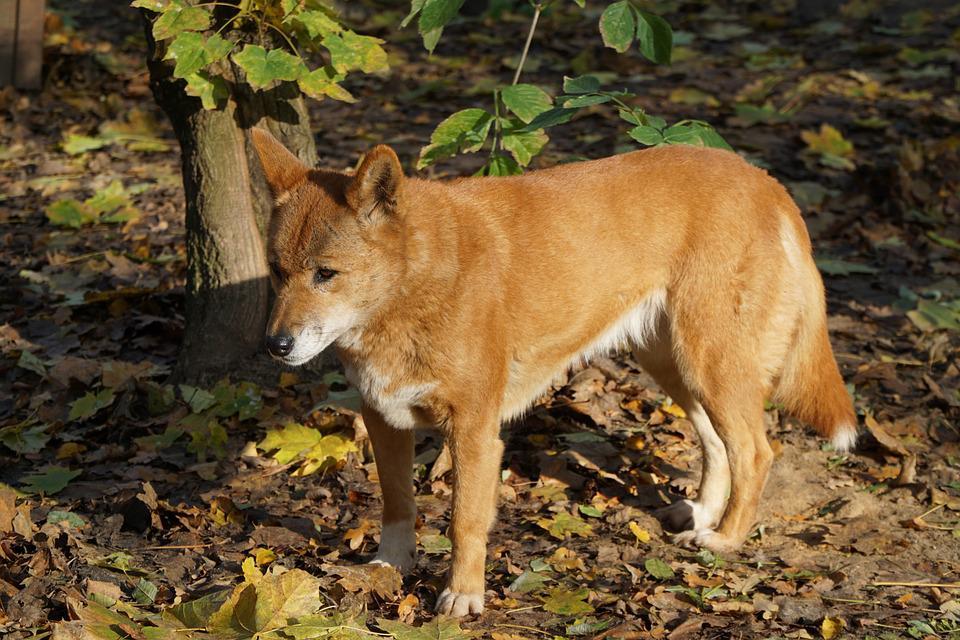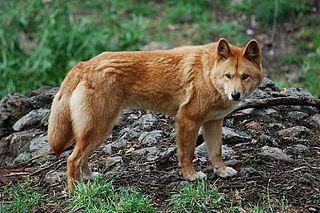The first image is the image on the left, the second image is the image on the right. Considering the images on both sides, is "The same number of canines are shown in the left and right images." valid? Answer yes or no. Yes. 